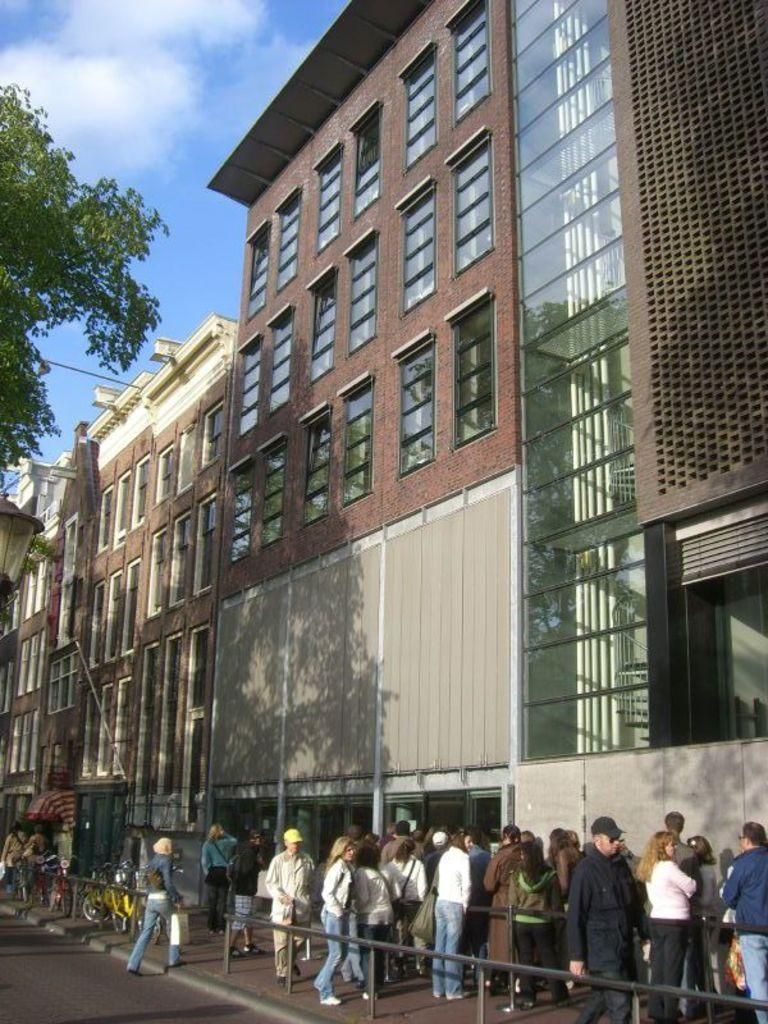What type of barrier can be seen in the image? There is a fence in the image. What natural element is present in the image? There is a tree in the image. What are the people in the image doing? The people are standing on the ground in the image. What mode of transportation is visible in the image? There are bicycles in the image. What can be seen in the background of the image? The sky is visible in the background of the image. Reasoning: Let's think step by following the steps to produce the conversation. We start by identifying the main subjects and objects in the image based on the provided facts. We then formulate questions that focus on the location and characteristics of these subjects and objects, ensuring that each question can be answered definitively with the information given. We avoid yes/no questions and ensure that the language is simple and clear. Absurd Question/Answer: How does the tree sort the leaves in the image? Trees do not sort leaves; they naturally grow and shed leaves. Can you see anyone getting a haircut in the image? There is no haircut or person getting a haircut visible in the image. How does the tree roll the bicycles in the image? Trees do not roll bicycles; they are stationary natural elements. Can you see anyone getting a haircut in the image? There is no haircut or person getting a haircut visible in the image. 